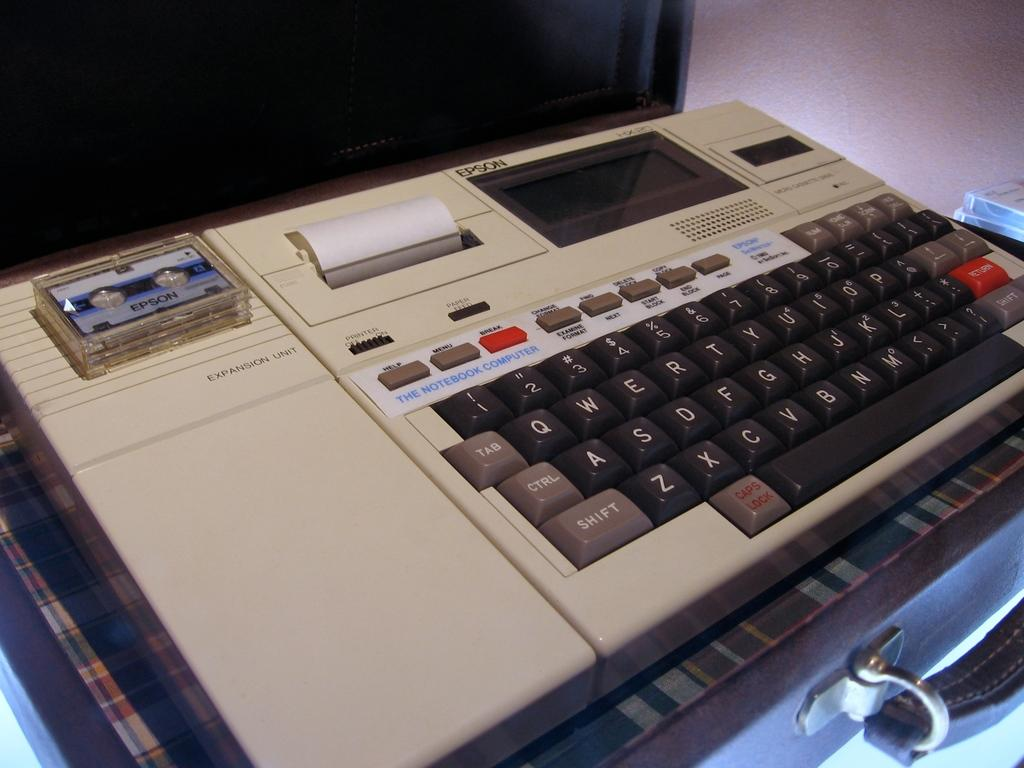<image>
Offer a succinct explanation of the picture presented. An old style office machine called an expansion unit. 